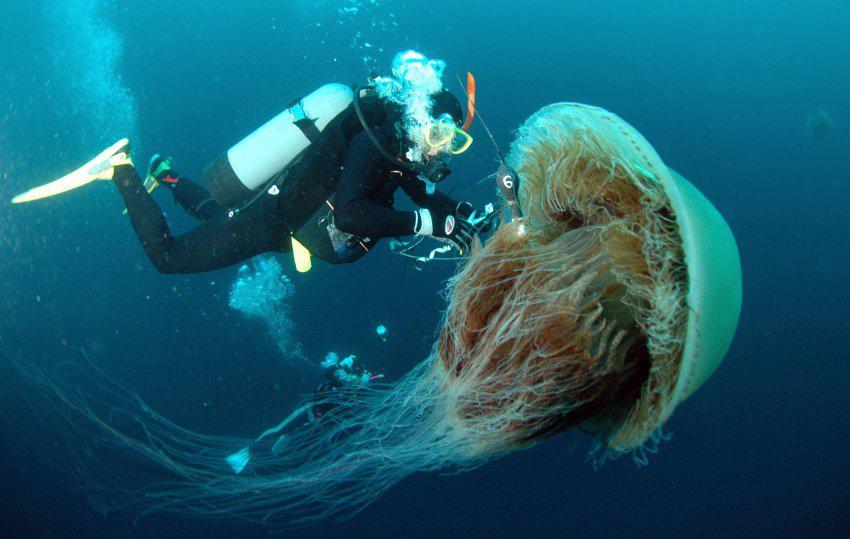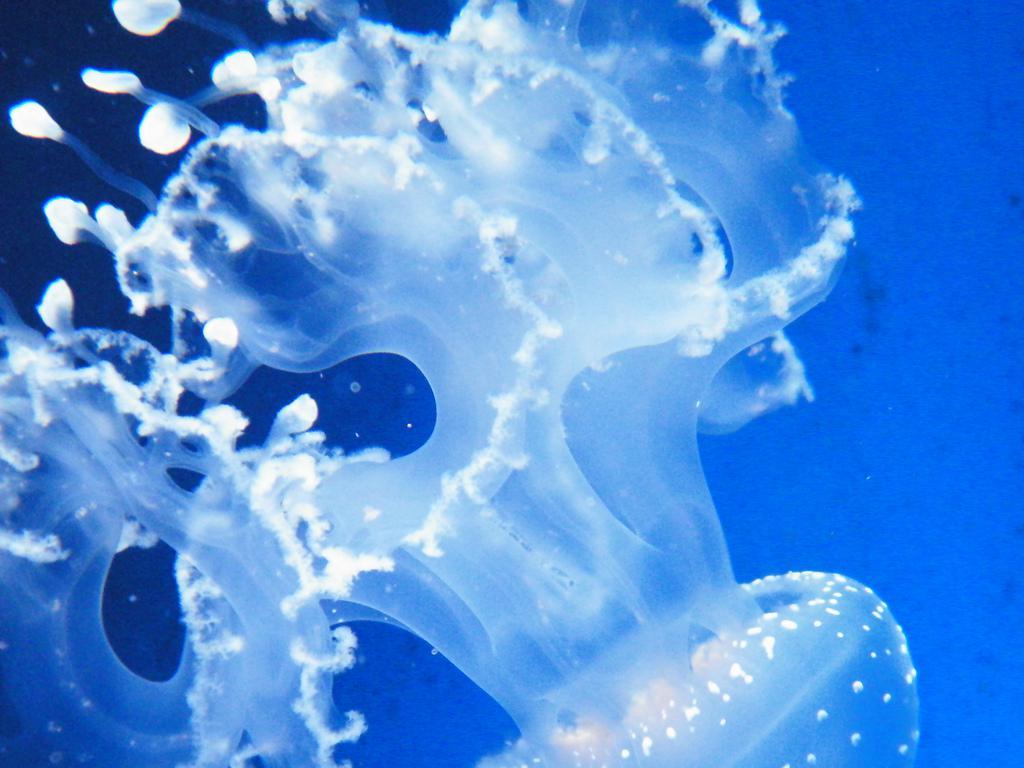The first image is the image on the left, the second image is the image on the right. For the images shown, is this caption "the jellyfish in the left image is swimming to the right" true? Answer yes or no. Yes. The first image is the image on the left, the second image is the image on the right. For the images shown, is this caption "The jellyfish in the image to the left has a distinct clover type image visible within its body." true? Answer yes or no. No. 